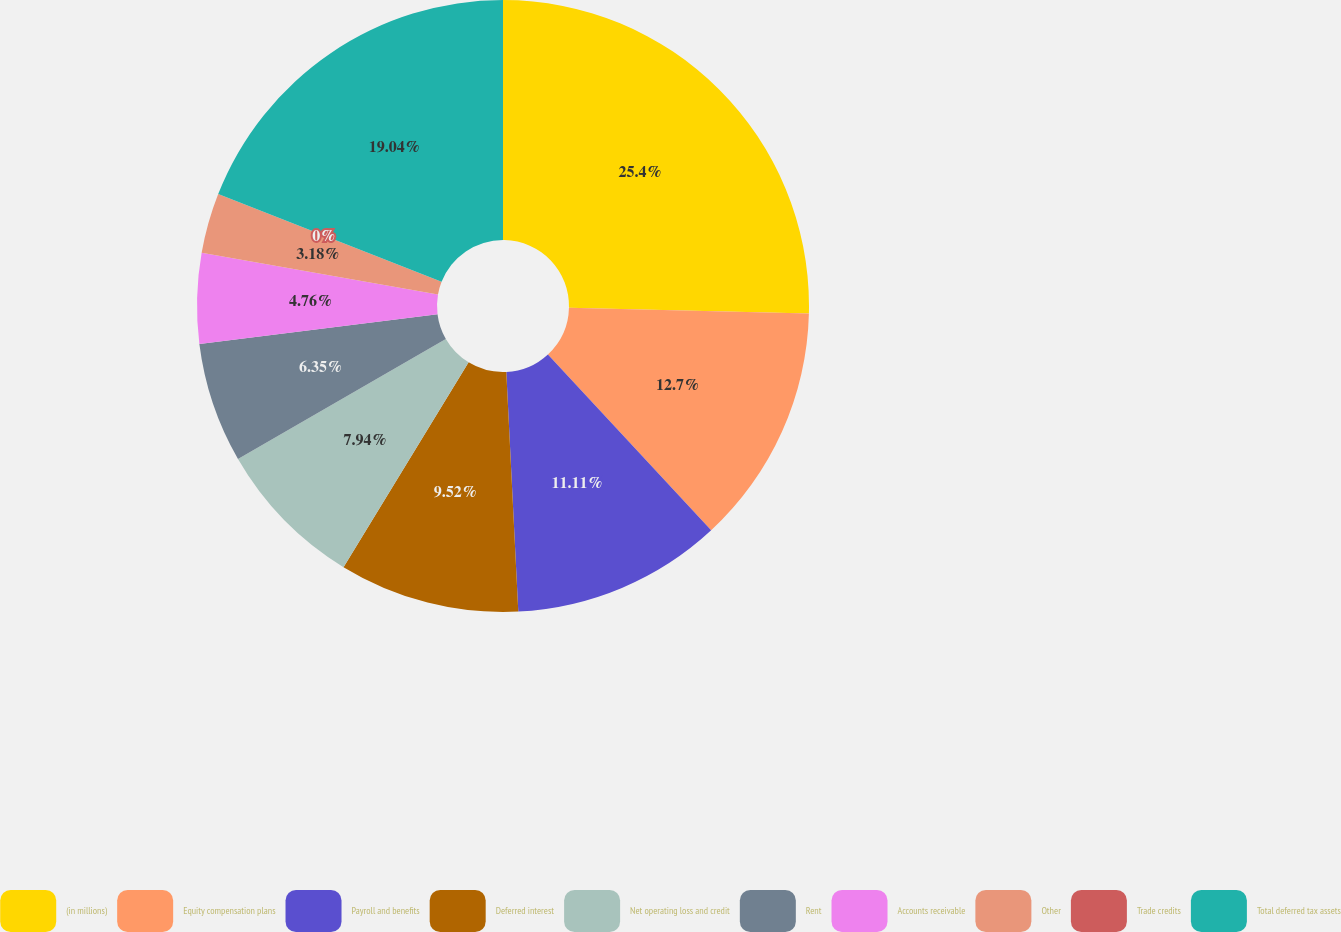Convert chart to OTSL. <chart><loc_0><loc_0><loc_500><loc_500><pie_chart><fcel>(in millions)<fcel>Equity compensation plans<fcel>Payroll and benefits<fcel>Deferred interest<fcel>Net operating loss and credit<fcel>Rent<fcel>Accounts receivable<fcel>Other<fcel>Trade credits<fcel>Total deferred tax assets<nl><fcel>25.39%<fcel>12.7%<fcel>11.11%<fcel>9.52%<fcel>7.94%<fcel>6.35%<fcel>4.76%<fcel>3.18%<fcel>0.0%<fcel>19.04%<nl></chart> 